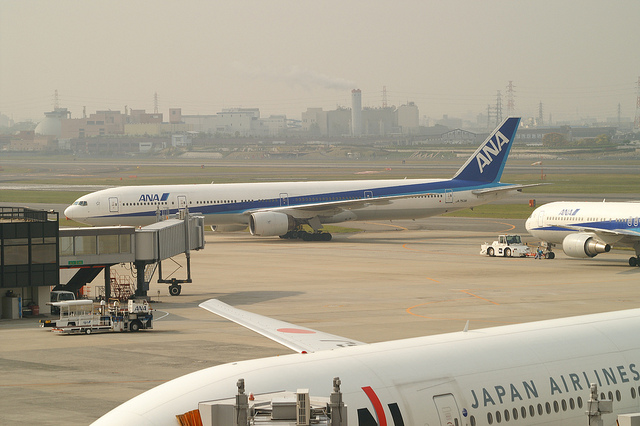What airline is depicted on the airplane connected to the aerobridge? The airplane connected to the aerobridge has 'ANA' painted on its side, which stands for All Nippon Airways, a major Japanese airline. 